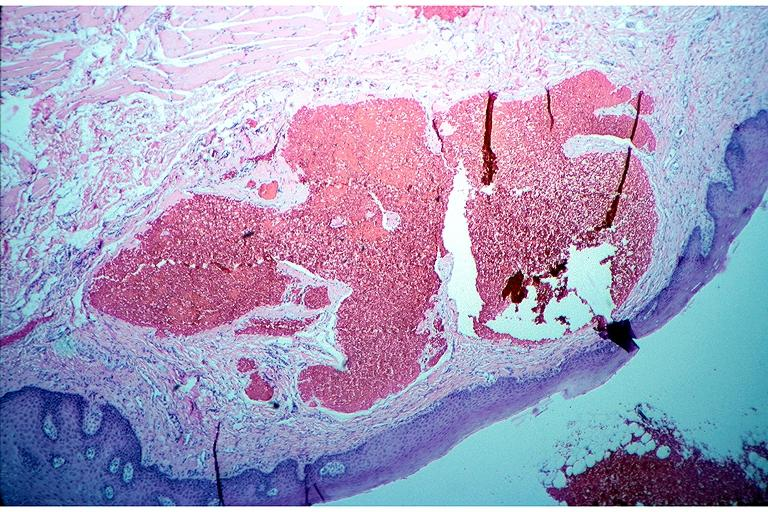where is this?
Answer the question using a single word or phrase. Oral 